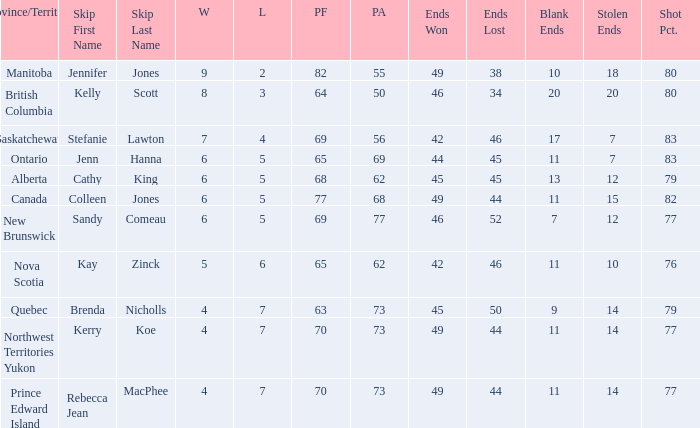When the pf is 77, what is the value of the pa? 68.0. 